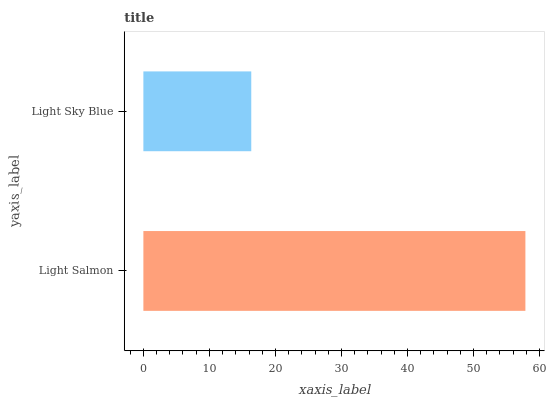Is Light Sky Blue the minimum?
Answer yes or no. Yes. Is Light Salmon the maximum?
Answer yes or no. Yes. Is Light Sky Blue the maximum?
Answer yes or no. No. Is Light Salmon greater than Light Sky Blue?
Answer yes or no. Yes. Is Light Sky Blue less than Light Salmon?
Answer yes or no. Yes. Is Light Sky Blue greater than Light Salmon?
Answer yes or no. No. Is Light Salmon less than Light Sky Blue?
Answer yes or no. No. Is Light Salmon the high median?
Answer yes or no. Yes. Is Light Sky Blue the low median?
Answer yes or no. Yes. Is Light Sky Blue the high median?
Answer yes or no. No. Is Light Salmon the low median?
Answer yes or no. No. 